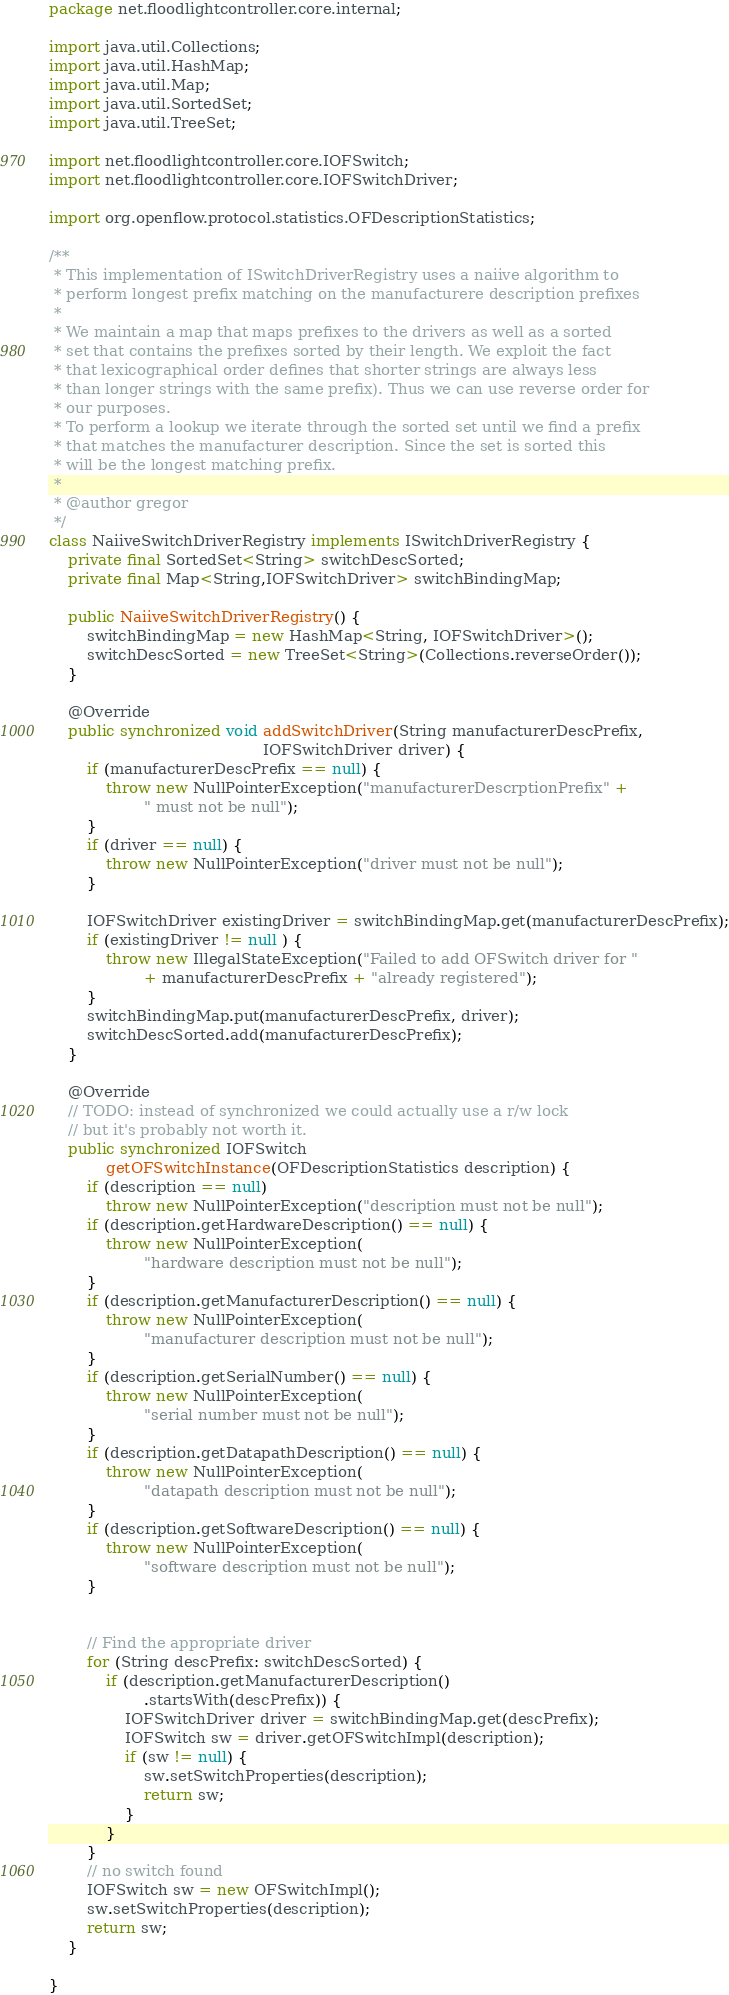<code> <loc_0><loc_0><loc_500><loc_500><_Java_>package net.floodlightcontroller.core.internal;

import java.util.Collections;
import java.util.HashMap;
import java.util.Map;
import java.util.SortedSet;
import java.util.TreeSet;

import net.floodlightcontroller.core.IOFSwitch;
import net.floodlightcontroller.core.IOFSwitchDriver;

import org.openflow.protocol.statistics.OFDescriptionStatistics;

/**
 * This implementation of ISwitchDriverRegistry uses a naiive algorithm to
 * perform longest prefix matching on the manufacturere description prefixes
 *
 * We maintain a map that maps prefixes to the drivers as well as a sorted
 * set that contains the prefixes sorted by their length. We exploit the fact
 * that lexicographical order defines that shorter strings are always less
 * than longer strings with the same prefix). Thus we can use reverse order for
 * our purposes.
 * To perform a lookup we iterate through the sorted set until we find a prefix
 * that matches the manufacturer description. Since the set is sorted this
 * will be the longest matching prefix.
 *
 * @author gregor
 */
class NaiiveSwitchDriverRegistry implements ISwitchDriverRegistry {
    private final SortedSet<String> switchDescSorted;
    private final Map<String,IOFSwitchDriver> switchBindingMap;

    public NaiiveSwitchDriverRegistry() {
        switchBindingMap = new HashMap<String, IOFSwitchDriver>();
        switchDescSorted = new TreeSet<String>(Collections.reverseOrder());
    }

    @Override
    public synchronized void addSwitchDriver(String manufacturerDescPrefix,
                                             IOFSwitchDriver driver) {
        if (manufacturerDescPrefix == null) {
            throw new NullPointerException("manufacturerDescrptionPrefix" +
                    " must not be null");
        }
        if (driver == null) {
            throw new NullPointerException("driver must not be null");
        }

        IOFSwitchDriver existingDriver = switchBindingMap.get(manufacturerDescPrefix);
        if (existingDriver != null ) {
            throw new IllegalStateException("Failed to add OFSwitch driver for "
                    + manufacturerDescPrefix + "already registered");
        }
        switchBindingMap.put(manufacturerDescPrefix, driver);
        switchDescSorted.add(manufacturerDescPrefix);
    }

    @Override
    // TODO: instead of synchronized we could actually use a r/w lock
    // but it's probably not worth it.
    public synchronized IOFSwitch
            getOFSwitchInstance(OFDescriptionStatistics description) {
        if (description == null)
            throw new NullPointerException("description must not be null");
        if (description.getHardwareDescription() == null) {
            throw new NullPointerException(
                    "hardware description must not be null");
        }
        if (description.getManufacturerDescription() == null) {
            throw new NullPointerException(
                    "manufacturer description must not be null");
        }
        if (description.getSerialNumber() == null) {
            throw new NullPointerException(
                    "serial number must not be null");
        }
        if (description.getDatapathDescription() == null) {
            throw new NullPointerException(
                    "datapath description must not be null");
        }
        if (description.getSoftwareDescription() == null) {
            throw new NullPointerException(
                    "software description must not be null");
        }


        // Find the appropriate driver
        for (String descPrefix: switchDescSorted) {
            if (description.getManufacturerDescription()
                    .startsWith(descPrefix)) {
                IOFSwitchDriver driver = switchBindingMap.get(descPrefix);
                IOFSwitch sw = driver.getOFSwitchImpl(description);
                if (sw != null) {
                    sw.setSwitchProperties(description);
                    return sw;
                }
            }
        }
        // no switch found
        IOFSwitch sw = new OFSwitchImpl();
        sw.setSwitchProperties(description);
        return sw;
    }

}
</code> 